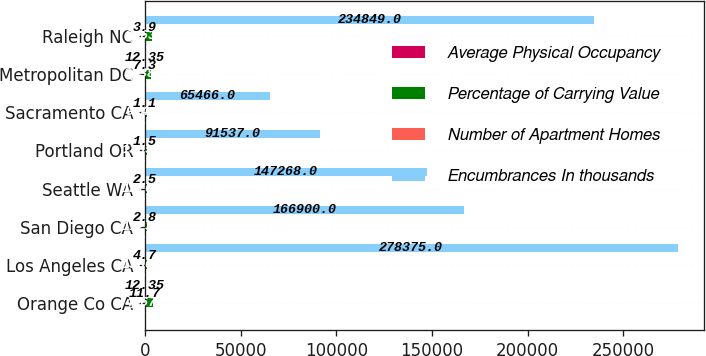Convert chart to OTSL. <chart><loc_0><loc_0><loc_500><loc_500><stacked_bar_chart><ecel><fcel>Orange Co CA<fcel>Los Angeles CA<fcel>San Diego CA<fcel>Seattle WA<fcel>Portland OR<fcel>Sacramento CA<fcel>Metropolitan DC<fcel>Raleigh NC<nl><fcel>Average Physical Occupancy<fcel>13<fcel>7<fcel>5<fcel>7<fcel>5<fcel>2<fcel>10<fcel>11<nl><fcel>Percentage of Carrying Value<fcel>4067<fcel>1380<fcel>1123<fcel>1270<fcel>1365<fcel>914<fcel>3138<fcel>3663<nl><fcel>Number of Apartment Homes<fcel>11.7<fcel>4.7<fcel>2.8<fcel>2.5<fcel>1.5<fcel>1.1<fcel>7.3<fcel>3.9<nl><fcel>Encumbrances In thousands<fcel>12.35<fcel>278375<fcel>166900<fcel>147268<fcel>91537<fcel>65466<fcel>12.35<fcel>234849<nl></chart> 